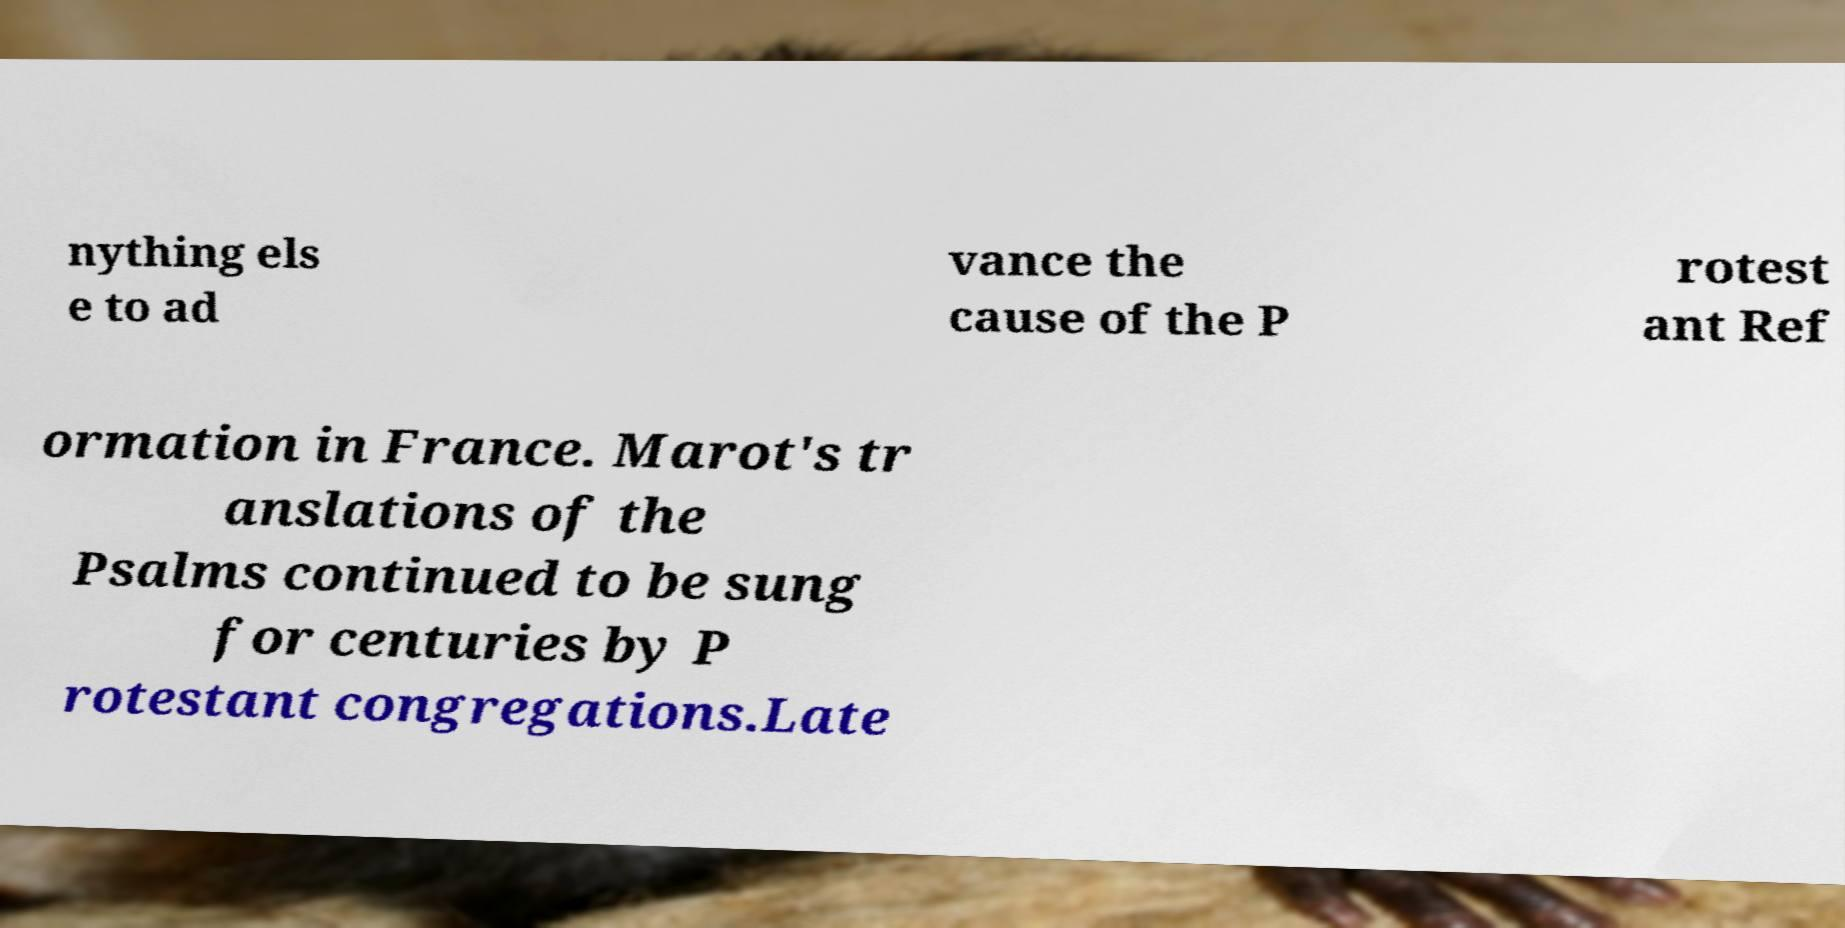Please identify and transcribe the text found in this image. nything els e to ad vance the cause of the P rotest ant Ref ormation in France. Marot's tr anslations of the Psalms continued to be sung for centuries by P rotestant congregations.Late 